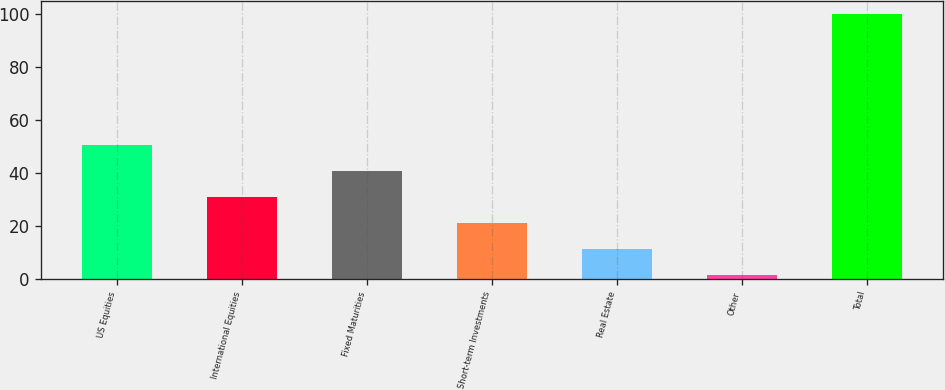Convert chart to OTSL. <chart><loc_0><loc_0><loc_500><loc_500><bar_chart><fcel>US Equities<fcel>International Equities<fcel>Fixed Maturities<fcel>Short-term Investments<fcel>Real Estate<fcel>Other<fcel>Total<nl><fcel>50.69<fcel>30.97<fcel>40.83<fcel>21.11<fcel>11.25<fcel>1.39<fcel>100<nl></chart> 